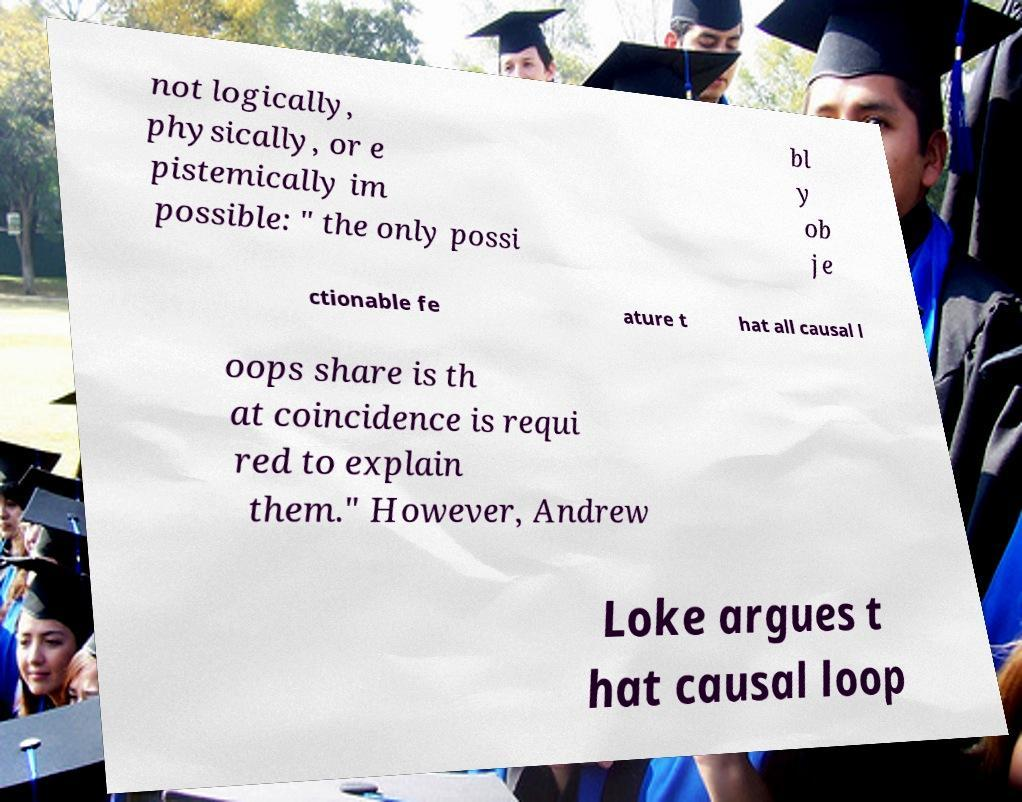Can you read and provide the text displayed in the image?This photo seems to have some interesting text. Can you extract and type it out for me? not logically, physically, or e pistemically im possible: " the only possi bl y ob je ctionable fe ature t hat all causal l oops share is th at coincidence is requi red to explain them." However, Andrew Loke argues t hat causal loop 